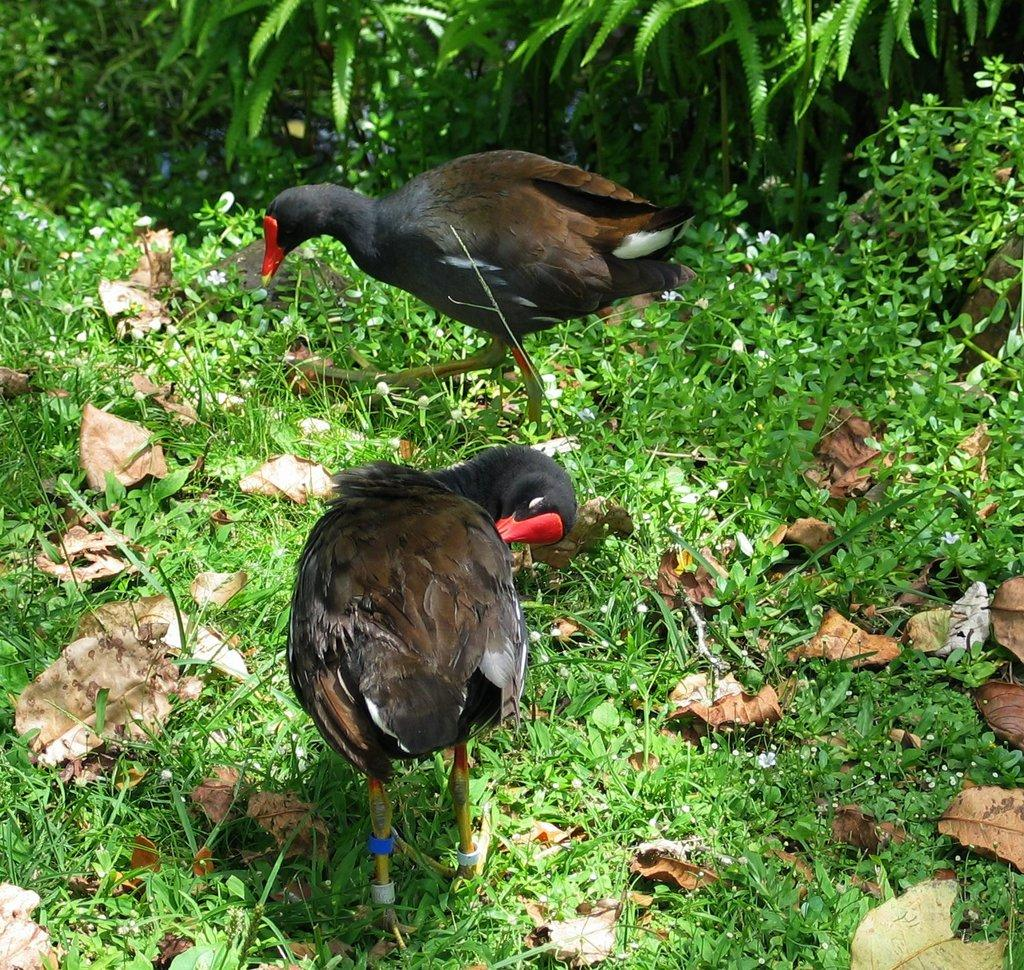How many birds can be seen in the image? There are two birds in the image. What else is present in the image besides the birds? Dry leaves, grass, and plants are present in the image. Can you describe the vegetation in the image? Grass and plants are visible in the image. What type of yam is being prepared by the secretary in the image? There is no secretary or yam present in the image; it features two birds, dry leaves, grass, and plants. 